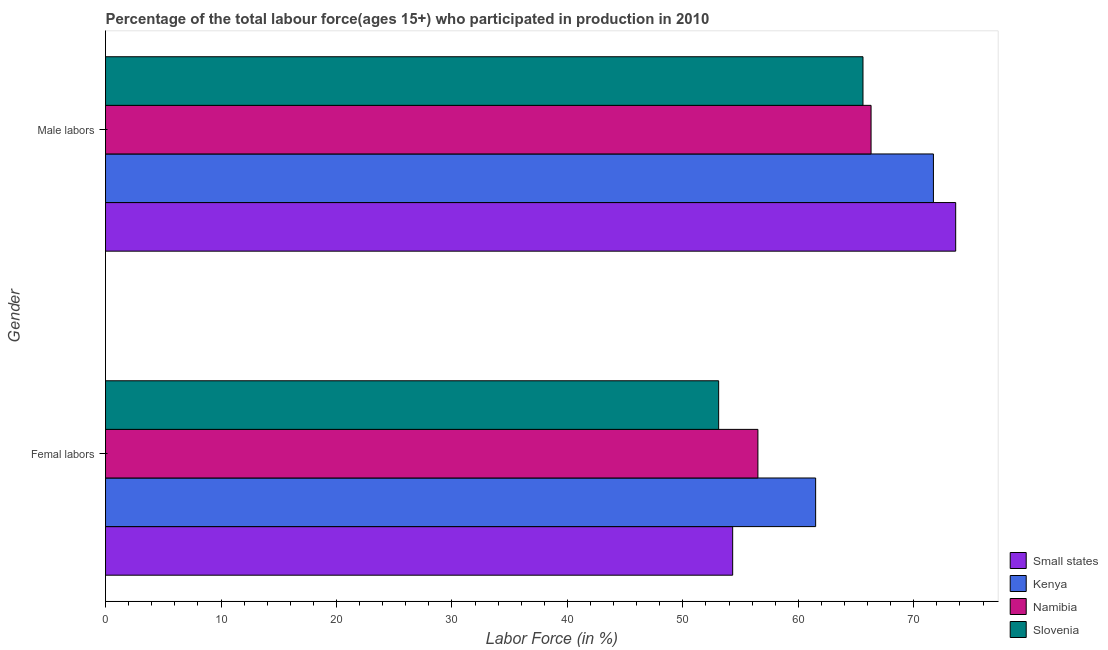What is the label of the 1st group of bars from the top?
Your response must be concise. Male labors. What is the percentage of male labour force in Namibia?
Keep it short and to the point. 66.3. Across all countries, what is the maximum percentage of male labour force?
Make the answer very short. 73.63. Across all countries, what is the minimum percentage of female labor force?
Provide a succinct answer. 53.1. In which country was the percentage of female labor force maximum?
Make the answer very short. Kenya. In which country was the percentage of female labor force minimum?
Make the answer very short. Slovenia. What is the total percentage of female labor force in the graph?
Ensure brevity in your answer.  225.41. What is the difference between the percentage of male labour force in Namibia and that in Kenya?
Provide a succinct answer. -5.4. What is the difference between the percentage of male labour force in Namibia and the percentage of female labor force in Small states?
Give a very brief answer. 11.99. What is the average percentage of male labour force per country?
Your answer should be compact. 69.31. What is the difference between the percentage of male labour force and percentage of female labor force in Small states?
Make the answer very short. 19.31. What is the ratio of the percentage of male labour force in Slovenia to that in Kenya?
Give a very brief answer. 0.91. In how many countries, is the percentage of female labor force greater than the average percentage of female labor force taken over all countries?
Give a very brief answer. 2. What does the 4th bar from the top in Femal labors represents?
Provide a succinct answer. Small states. What does the 4th bar from the bottom in Male labors represents?
Your answer should be very brief. Slovenia. How many bars are there?
Your answer should be very brief. 8. Are all the bars in the graph horizontal?
Give a very brief answer. Yes. What is the difference between two consecutive major ticks on the X-axis?
Your answer should be compact. 10. Are the values on the major ticks of X-axis written in scientific E-notation?
Give a very brief answer. No. Does the graph contain any zero values?
Make the answer very short. No. Does the graph contain grids?
Offer a very short reply. No. Where does the legend appear in the graph?
Your response must be concise. Bottom right. How many legend labels are there?
Provide a succinct answer. 4. How are the legend labels stacked?
Ensure brevity in your answer.  Vertical. What is the title of the graph?
Your answer should be compact. Percentage of the total labour force(ages 15+) who participated in production in 2010. What is the Labor Force (in %) of Small states in Femal labors?
Your response must be concise. 54.31. What is the Labor Force (in %) in Kenya in Femal labors?
Provide a succinct answer. 61.5. What is the Labor Force (in %) in Namibia in Femal labors?
Provide a short and direct response. 56.5. What is the Labor Force (in %) of Slovenia in Femal labors?
Ensure brevity in your answer.  53.1. What is the Labor Force (in %) of Small states in Male labors?
Provide a succinct answer. 73.63. What is the Labor Force (in %) in Kenya in Male labors?
Make the answer very short. 71.7. What is the Labor Force (in %) of Namibia in Male labors?
Your answer should be compact. 66.3. What is the Labor Force (in %) in Slovenia in Male labors?
Provide a succinct answer. 65.6. Across all Gender, what is the maximum Labor Force (in %) in Small states?
Provide a succinct answer. 73.63. Across all Gender, what is the maximum Labor Force (in %) of Kenya?
Offer a very short reply. 71.7. Across all Gender, what is the maximum Labor Force (in %) in Namibia?
Ensure brevity in your answer.  66.3. Across all Gender, what is the maximum Labor Force (in %) in Slovenia?
Offer a terse response. 65.6. Across all Gender, what is the minimum Labor Force (in %) of Small states?
Your response must be concise. 54.31. Across all Gender, what is the minimum Labor Force (in %) in Kenya?
Keep it short and to the point. 61.5. Across all Gender, what is the minimum Labor Force (in %) of Namibia?
Provide a succinct answer. 56.5. Across all Gender, what is the minimum Labor Force (in %) of Slovenia?
Your answer should be very brief. 53.1. What is the total Labor Force (in %) in Small states in the graph?
Ensure brevity in your answer.  127.94. What is the total Labor Force (in %) in Kenya in the graph?
Provide a short and direct response. 133.2. What is the total Labor Force (in %) in Namibia in the graph?
Give a very brief answer. 122.8. What is the total Labor Force (in %) in Slovenia in the graph?
Offer a very short reply. 118.7. What is the difference between the Labor Force (in %) of Small states in Femal labors and that in Male labors?
Ensure brevity in your answer.  -19.31. What is the difference between the Labor Force (in %) of Kenya in Femal labors and that in Male labors?
Ensure brevity in your answer.  -10.2. What is the difference between the Labor Force (in %) of Namibia in Femal labors and that in Male labors?
Make the answer very short. -9.8. What is the difference between the Labor Force (in %) in Small states in Femal labors and the Labor Force (in %) in Kenya in Male labors?
Keep it short and to the point. -17.39. What is the difference between the Labor Force (in %) of Small states in Femal labors and the Labor Force (in %) of Namibia in Male labors?
Your answer should be very brief. -11.99. What is the difference between the Labor Force (in %) in Small states in Femal labors and the Labor Force (in %) in Slovenia in Male labors?
Ensure brevity in your answer.  -11.29. What is the difference between the Labor Force (in %) in Kenya in Femal labors and the Labor Force (in %) in Slovenia in Male labors?
Provide a short and direct response. -4.1. What is the difference between the Labor Force (in %) in Namibia in Femal labors and the Labor Force (in %) in Slovenia in Male labors?
Give a very brief answer. -9.1. What is the average Labor Force (in %) of Small states per Gender?
Give a very brief answer. 63.97. What is the average Labor Force (in %) in Kenya per Gender?
Provide a short and direct response. 66.6. What is the average Labor Force (in %) in Namibia per Gender?
Keep it short and to the point. 61.4. What is the average Labor Force (in %) of Slovenia per Gender?
Your answer should be compact. 59.35. What is the difference between the Labor Force (in %) of Small states and Labor Force (in %) of Kenya in Femal labors?
Offer a terse response. -7.19. What is the difference between the Labor Force (in %) of Small states and Labor Force (in %) of Namibia in Femal labors?
Give a very brief answer. -2.19. What is the difference between the Labor Force (in %) of Small states and Labor Force (in %) of Slovenia in Femal labors?
Give a very brief answer. 1.21. What is the difference between the Labor Force (in %) in Namibia and Labor Force (in %) in Slovenia in Femal labors?
Ensure brevity in your answer.  3.4. What is the difference between the Labor Force (in %) of Small states and Labor Force (in %) of Kenya in Male labors?
Ensure brevity in your answer.  1.93. What is the difference between the Labor Force (in %) in Small states and Labor Force (in %) in Namibia in Male labors?
Your answer should be very brief. 7.33. What is the difference between the Labor Force (in %) in Small states and Labor Force (in %) in Slovenia in Male labors?
Keep it short and to the point. 8.03. What is the difference between the Labor Force (in %) of Kenya and Labor Force (in %) of Namibia in Male labors?
Ensure brevity in your answer.  5.4. What is the difference between the Labor Force (in %) in Namibia and Labor Force (in %) in Slovenia in Male labors?
Give a very brief answer. 0.7. What is the ratio of the Labor Force (in %) of Small states in Femal labors to that in Male labors?
Offer a terse response. 0.74. What is the ratio of the Labor Force (in %) of Kenya in Femal labors to that in Male labors?
Ensure brevity in your answer.  0.86. What is the ratio of the Labor Force (in %) of Namibia in Femal labors to that in Male labors?
Make the answer very short. 0.85. What is the ratio of the Labor Force (in %) in Slovenia in Femal labors to that in Male labors?
Your answer should be very brief. 0.81. What is the difference between the highest and the second highest Labor Force (in %) of Small states?
Your answer should be compact. 19.31. What is the difference between the highest and the second highest Labor Force (in %) in Namibia?
Give a very brief answer. 9.8. What is the difference between the highest and the lowest Labor Force (in %) of Small states?
Offer a very short reply. 19.31. What is the difference between the highest and the lowest Labor Force (in %) in Slovenia?
Offer a terse response. 12.5. 